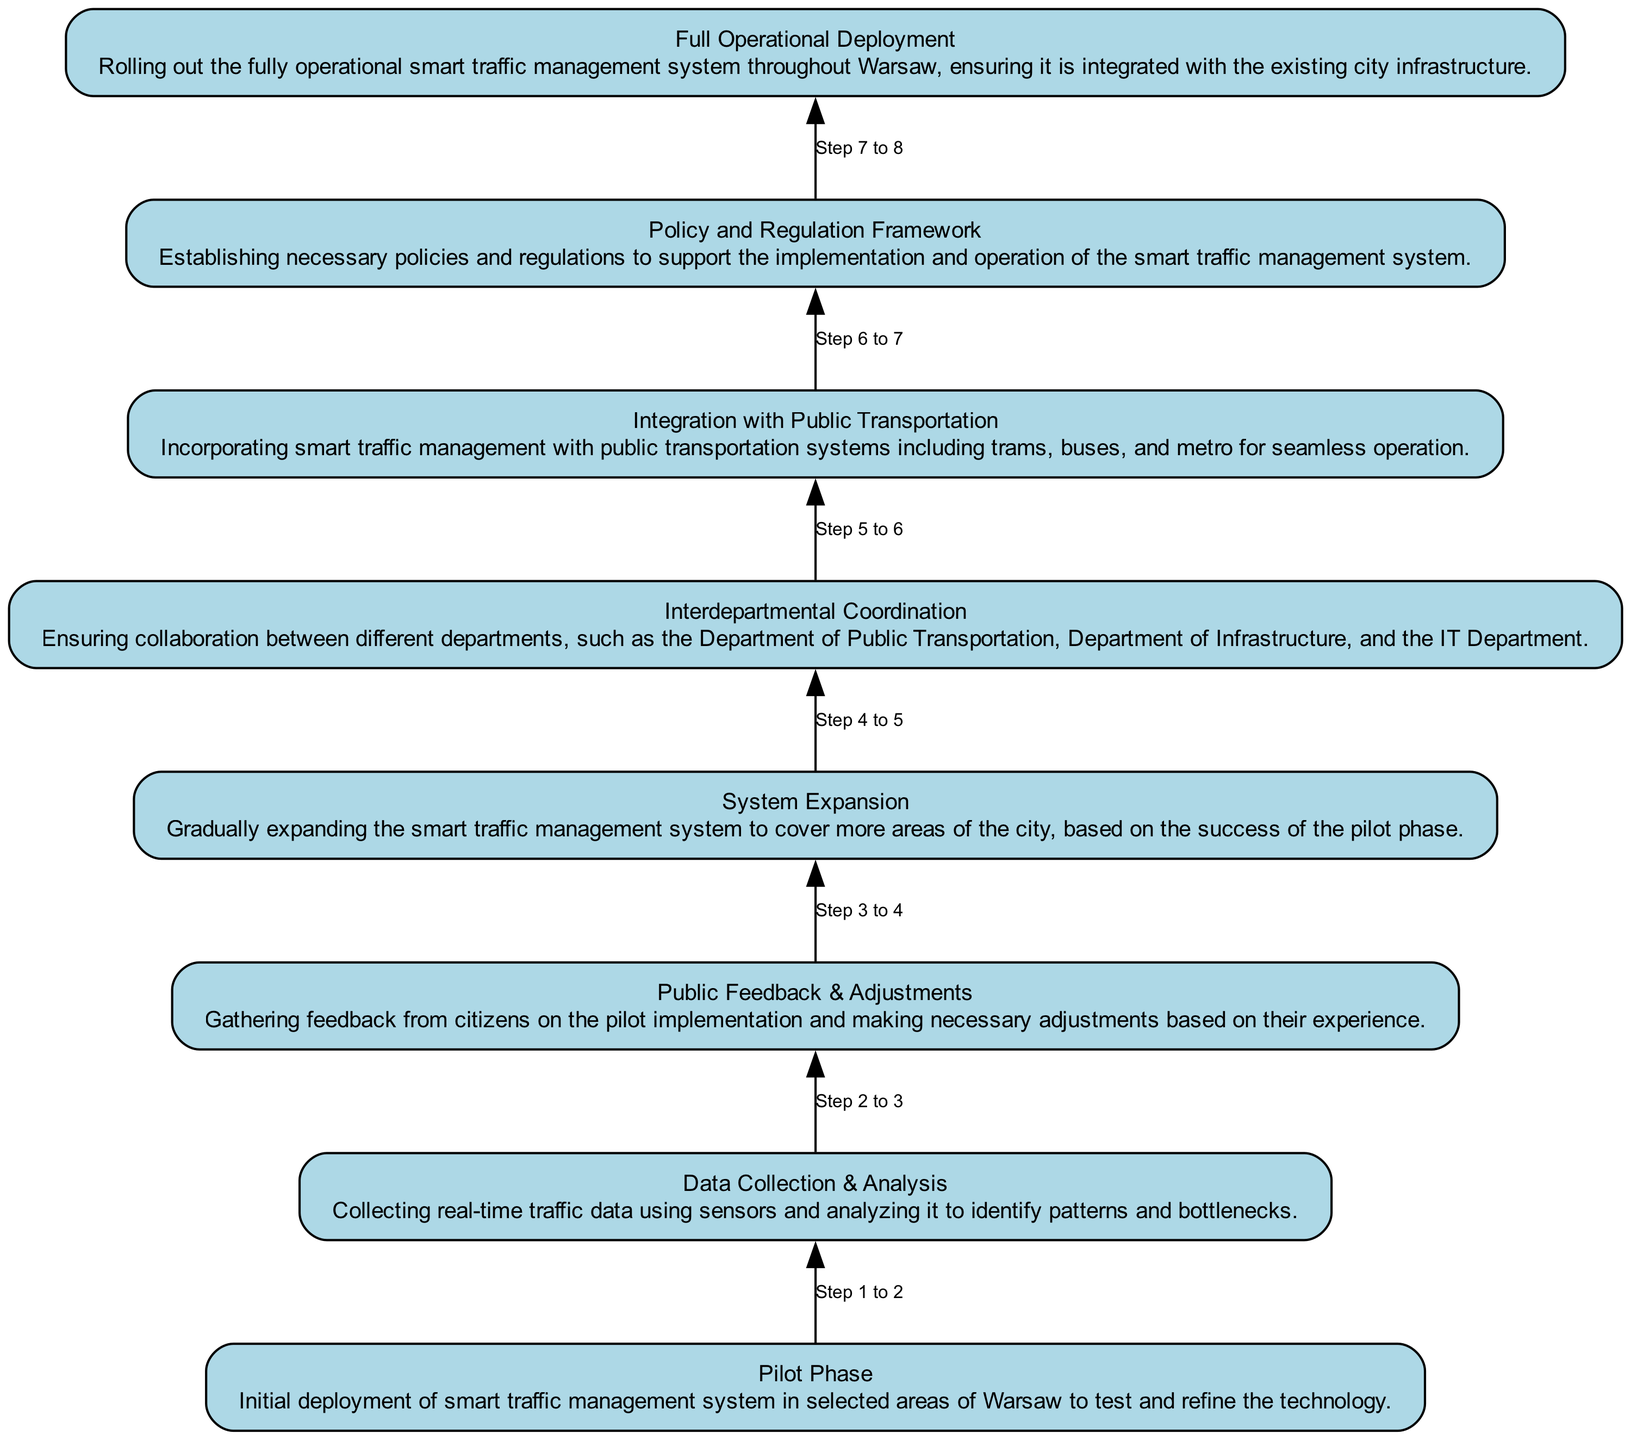What is the first phase in the integration process? The first phase listed in the diagram is "Pilot Phase." It is the starting point of the integration of the smart traffic management system.
Answer: Pilot Phase How many total phases are shown in the diagram? By counting the elements represented in the diagram, there are a total of eight phases listed.
Answer: 8 Which phase comes after "Data Collection & Analysis"? According to the flow in the diagram, "Public Feedback & Adjustments" follows directly after "Data Collection & Analysis."
Answer: Public Feedback & Adjustments What is the last phase in the integration of smart traffic management systems? The final node at the top of the flow indicates "Full Operational Deployment," which is the last phase in the integration process.
Answer: Full Operational Deployment Which steps require interdepartmental coordination? Looking through the phases, "Interdepartmental Coordination" is the step that specifically emphasizes the need for collaboration between departments, occurring before the integration step.
Answer: Interdepartmental Coordination What phase directly informs adjustments to the system? The "Public Feedback & Adjustments" phase involves gathering citizen feedback, which directly influences system adjustments.
Answer: Public Feedback & Adjustments How many flows or connections are there between the nodes? The diagram represents a total of seven flows or connections that show the progression from one phase to the next in the integration process.
Answer: 7 Which phase integrates public transportation systems? The node labeled "Integration with Public Transportation" specifically describes the incorporation of smart traffic management with public transit, identifying it as crucial for seamless operation.
Answer: Integration with Public Transportation What precedes the "Full Operational Deployment"? The diagram indicates that "Policy and Regulation Framework" comes immediately before the "Full Operational Deployment," emphasizing the need for established policies prior to full rollout.
Answer: Policy and Regulation Framework 